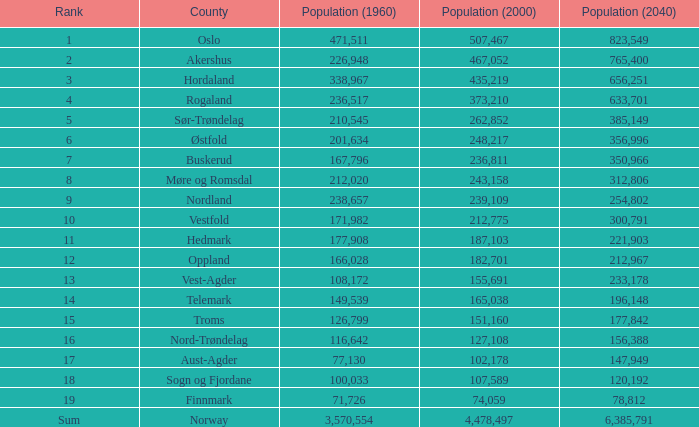What was the population of a county in 1960 that had a population of 467,052 in 2000 and 78,812 in 2040? None. 